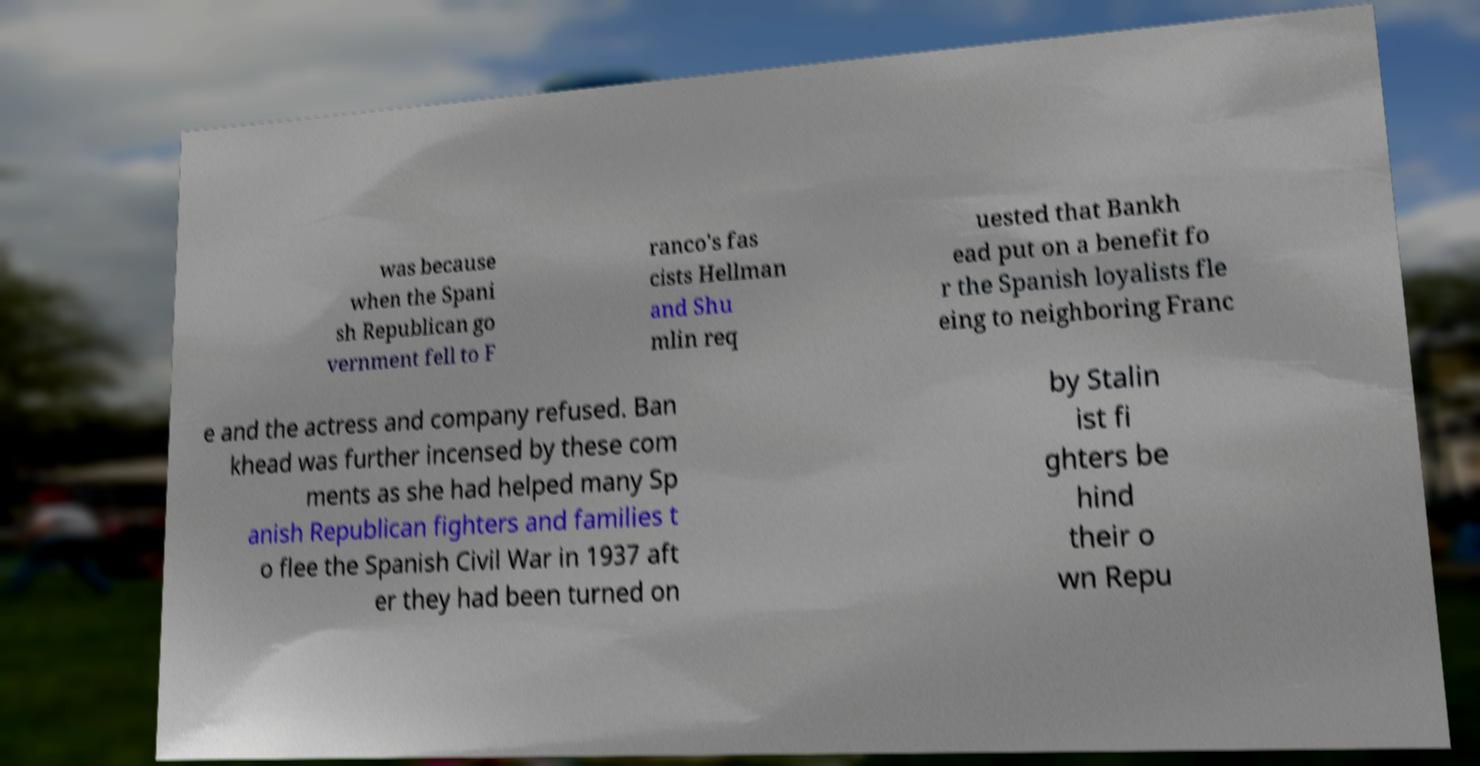For documentation purposes, I need the text within this image transcribed. Could you provide that? was because when the Spani sh Republican go vernment fell to F ranco's fas cists Hellman and Shu mlin req uested that Bankh ead put on a benefit fo r the Spanish loyalists fle eing to neighboring Franc e and the actress and company refused. Ban khead was further incensed by these com ments as she had helped many Sp anish Republican fighters and families t o flee the Spanish Civil War in 1937 aft er they had been turned on by Stalin ist fi ghters be hind their o wn Repu 